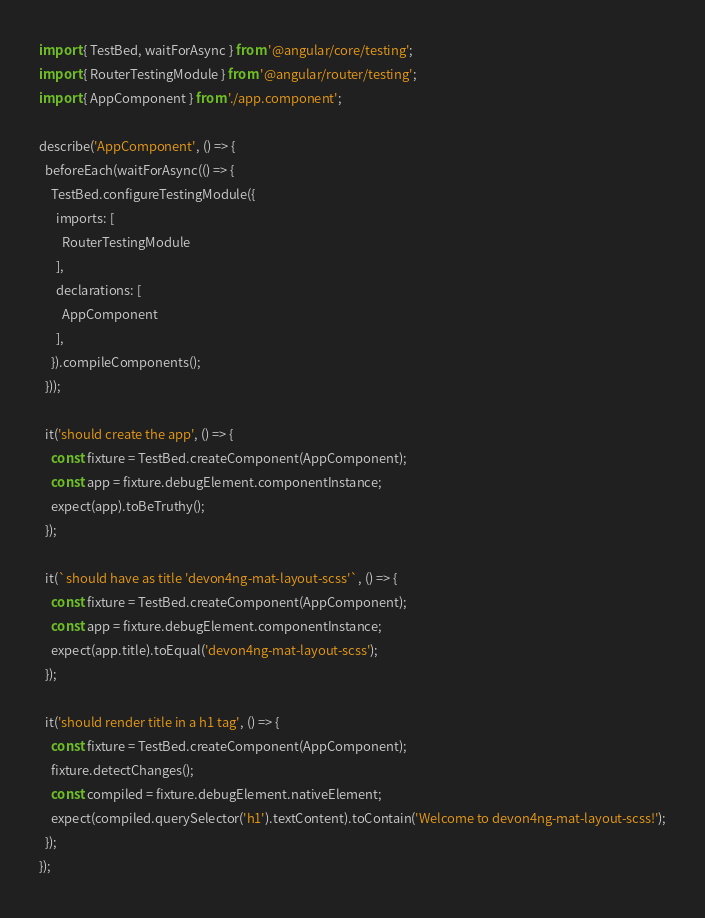<code> <loc_0><loc_0><loc_500><loc_500><_TypeScript_>import { TestBed, waitForAsync } from '@angular/core/testing';
import { RouterTestingModule } from '@angular/router/testing';
import { AppComponent } from './app.component';

describe('AppComponent', () => {
  beforeEach(waitForAsync(() => {
    TestBed.configureTestingModule({
      imports: [
        RouterTestingModule
      ],
      declarations: [
        AppComponent
      ],
    }).compileComponents();
  }));

  it('should create the app', () => {
    const fixture = TestBed.createComponent(AppComponent);
    const app = fixture.debugElement.componentInstance;
    expect(app).toBeTruthy();
  });

  it(`should have as title 'devon4ng-mat-layout-scss'`, () => {
    const fixture = TestBed.createComponent(AppComponent);
    const app = fixture.debugElement.componentInstance;
    expect(app.title).toEqual('devon4ng-mat-layout-scss');
  });

  it('should render title in a h1 tag', () => {
    const fixture = TestBed.createComponent(AppComponent);
    fixture.detectChanges();
    const compiled = fixture.debugElement.nativeElement;
    expect(compiled.querySelector('h1').textContent).toContain('Welcome to devon4ng-mat-layout-scss!');
  });
});
</code> 